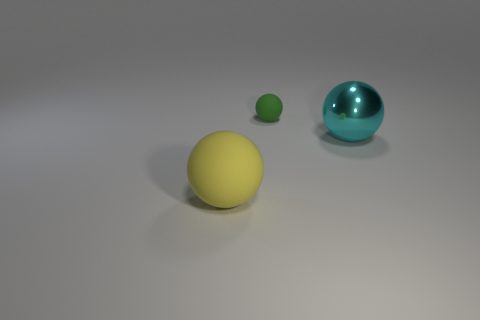Subtract all big balls. How many balls are left? 1 Add 1 red matte blocks. How many objects exist? 4 Subtract 1 spheres. How many spheres are left? 2 Subtract all blue blocks. How many purple balls are left? 0 Subtract all big cyan metallic balls. Subtract all large rubber spheres. How many objects are left? 1 Add 3 yellow things. How many yellow things are left? 4 Add 3 large red rubber blocks. How many large red rubber blocks exist? 3 Subtract 0 green cylinders. How many objects are left? 3 Subtract all yellow spheres. Subtract all red blocks. How many spheres are left? 2 